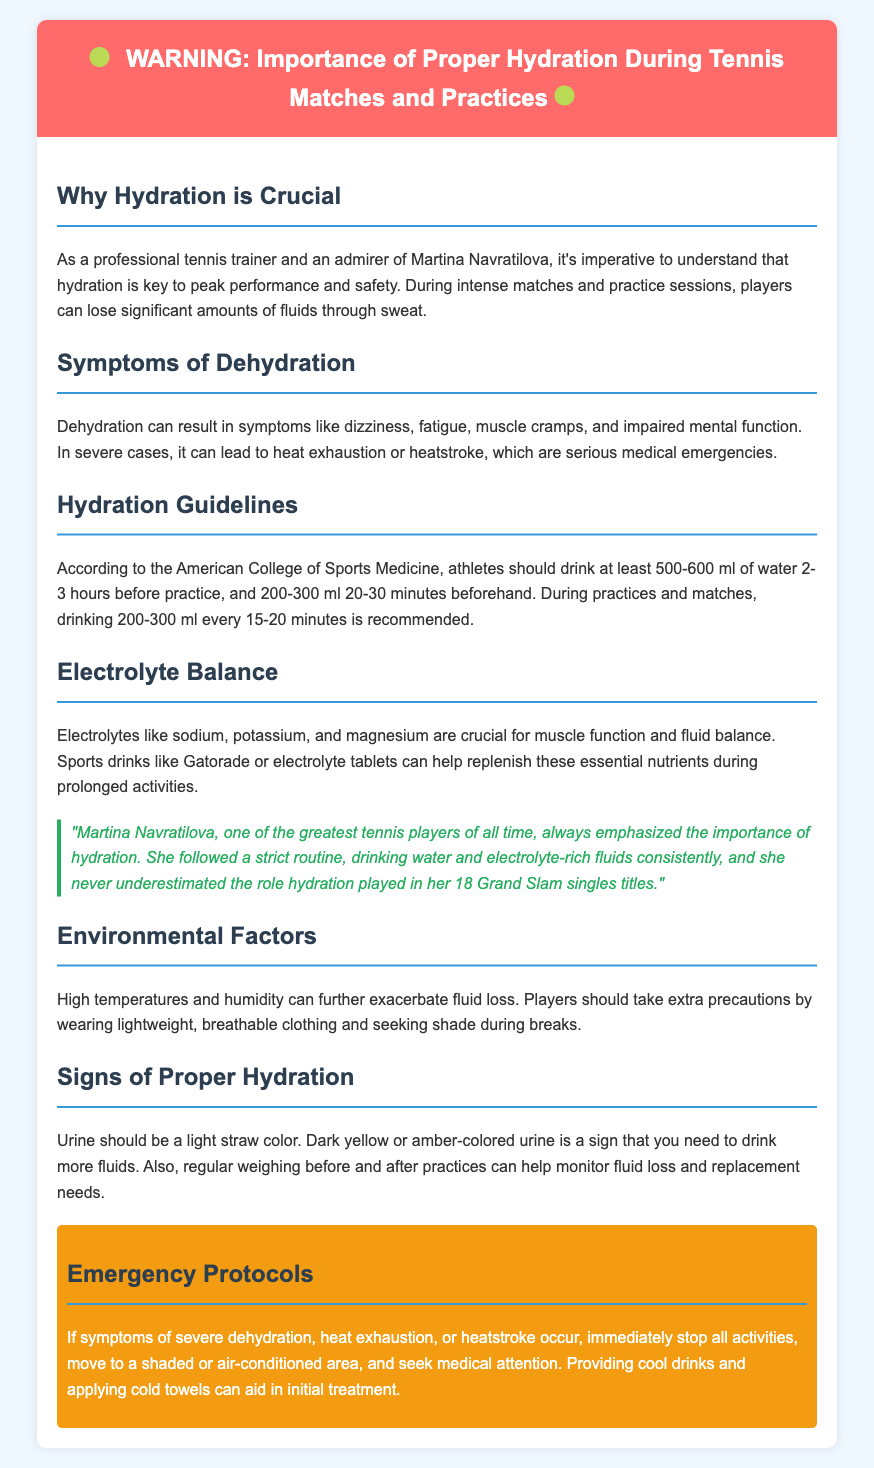What is the recommended fluid intake before practice? The document states that athletes should drink at least 500-600 ml of water 2-3 hours before practice.
Answer: 500-600 ml What symptoms indicate dehydration? The document lists dizziness, fatigue, muscle cramps, and impaired mental function as symptoms of dehydration.
Answer: Dizziness, fatigue, muscle cramps, impaired mental function How much water should be consumed during matches? The recommended intake is 200-300 ml every 15-20 minutes during practices and matches.
Answer: 200-300 ml What electrolyte is crucial for fluid balance? The document highlights sodium, potassium, and magnesium as crucial for muscle function and fluid balance.
Answer: Sodium, potassium, magnesium What color indicates proper hydration? Urine should be a light straw color to indicate proper hydration levels.
Answer: Light straw color What should be done in case of heat exhaustion? The document advises to immediately stop all activities and seek medical attention.
Answer: Seek medical attention What did Martina Navratilova emphasize? The document mentions that Martina emphasized the importance of hydration.
Answer: Importance of hydration What are environmental factors affecting hydration? High temperatures and humidity are mentioned as environmental factors that can exacerbate fluid loss.
Answer: High temperatures, humidity 